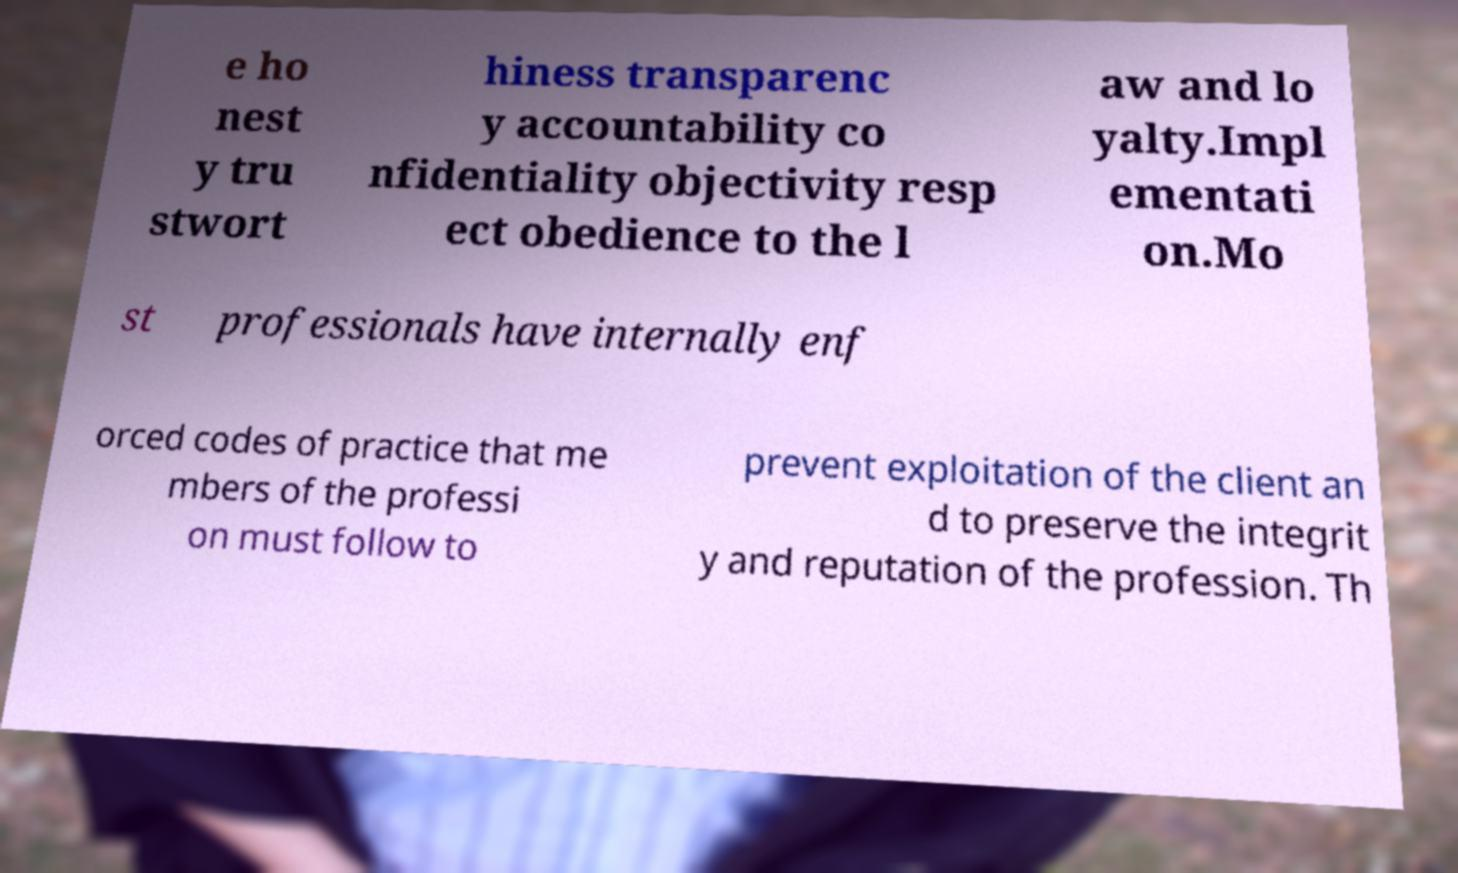Can you accurately transcribe the text from the provided image for me? e ho nest y tru stwort hiness transparenc y accountability co nfidentiality objectivity resp ect obedience to the l aw and lo yalty.Impl ementati on.Mo st professionals have internally enf orced codes of practice that me mbers of the professi on must follow to prevent exploitation of the client an d to preserve the integrit y and reputation of the profession. Th 